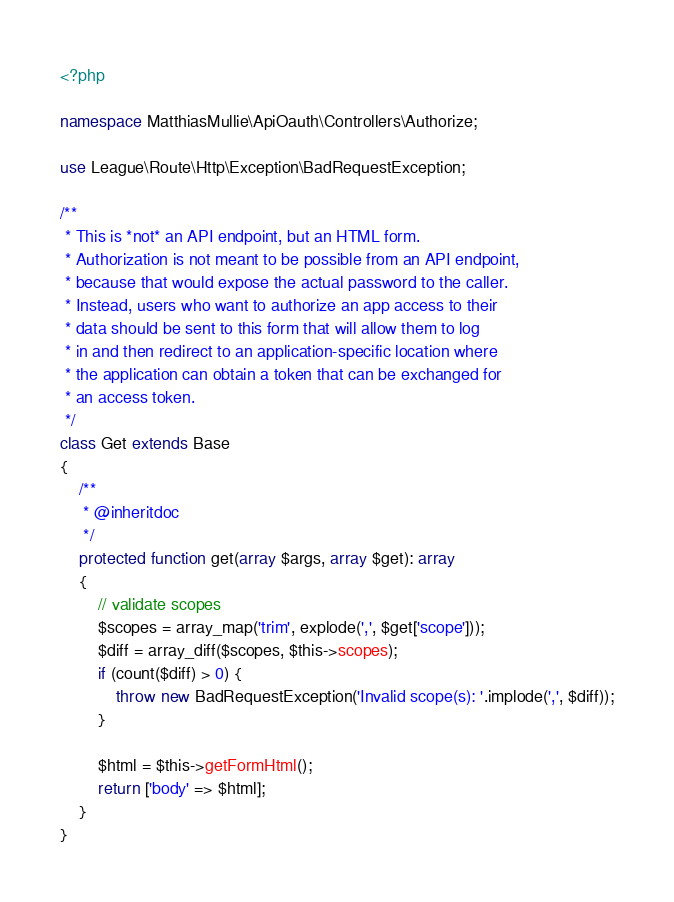Convert code to text. <code><loc_0><loc_0><loc_500><loc_500><_PHP_><?php

namespace MatthiasMullie\ApiOauth\Controllers\Authorize;

use League\Route\Http\Exception\BadRequestException;

/**
 * This is *not* an API endpoint, but an HTML form.
 * Authorization is not meant to be possible from an API endpoint,
 * because that would expose the actual password to the caller.
 * Instead, users who want to authorize an app access to their
 * data should be sent to this form that will allow them to log
 * in and then redirect to an application-specific location where
 * the application can obtain a token that can be exchanged for
 * an access token.
 */
class Get extends Base
{
    /**
     * @inheritdoc
     */
    protected function get(array $args, array $get): array
    {
        // validate scopes
        $scopes = array_map('trim', explode(',', $get['scope']));
        $diff = array_diff($scopes, $this->scopes);
        if (count($diff) > 0) {
            throw new BadRequestException('Invalid scope(s): '.implode(',', $diff));
        }

        $html = $this->getFormHtml();
        return ['body' => $html];
    }
}
</code> 